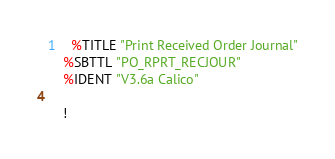<code> <loc_0><loc_0><loc_500><loc_500><_VisualBasic_>1	%TITLE "Print Received Order Journal"
	%SBTTL "PO_RPRT_RECJOUR"
	%IDENT "V3.6a Calico"

	!</code> 